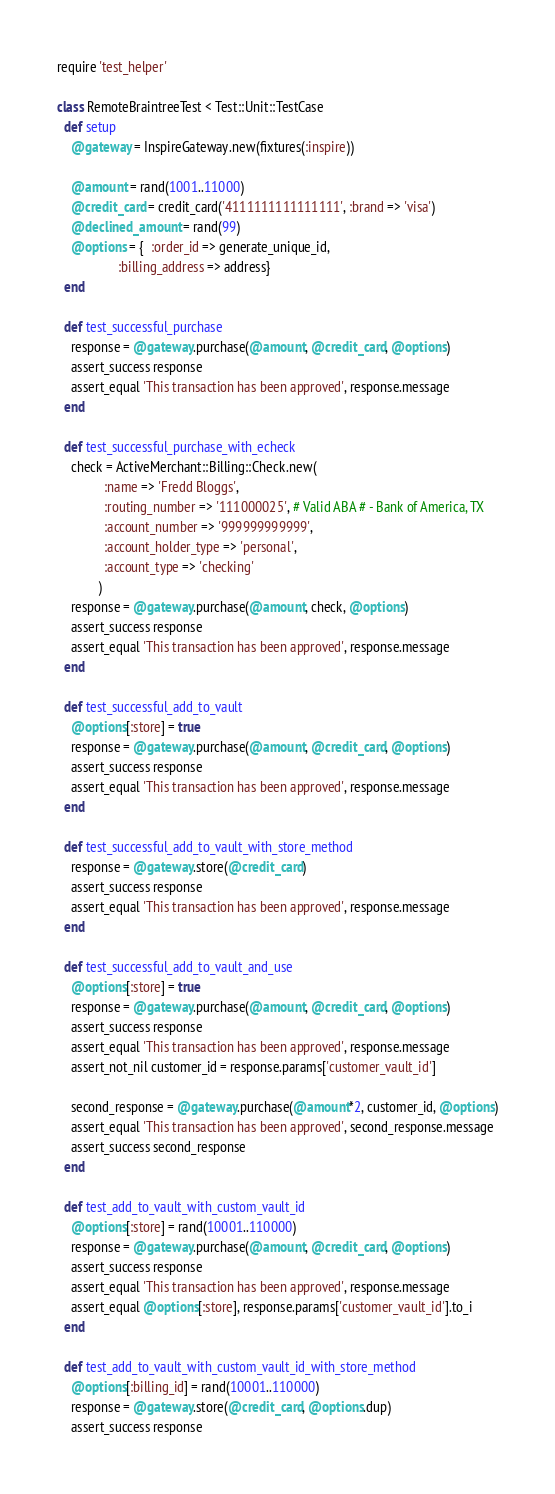<code> <loc_0><loc_0><loc_500><loc_500><_Ruby_>require 'test_helper'

class RemoteBraintreeTest < Test::Unit::TestCase
  def setup
    @gateway = InspireGateway.new(fixtures(:inspire))

    @amount = rand(1001..11000)
    @credit_card = credit_card('4111111111111111', :brand => 'visa')
    @declined_amount = rand(99)
    @options = {  :order_id => generate_unique_id,
                  :billing_address => address}
  end

  def test_successful_purchase
    response = @gateway.purchase(@amount, @credit_card, @options)
    assert_success response
    assert_equal 'This transaction has been approved', response.message
  end

  def test_successful_purchase_with_echeck
    check = ActiveMerchant::Billing::Check.new(
              :name => 'Fredd Bloggs',
              :routing_number => '111000025', # Valid ABA # - Bank of America, TX
              :account_number => '999999999999',
              :account_holder_type => 'personal',
              :account_type => 'checking'
            )
    response = @gateway.purchase(@amount, check, @options)
    assert_success response
    assert_equal 'This transaction has been approved', response.message
  end

  def test_successful_add_to_vault
    @options[:store] = true
    response = @gateway.purchase(@amount, @credit_card, @options)
    assert_success response
    assert_equal 'This transaction has been approved', response.message
  end

  def test_successful_add_to_vault_with_store_method
    response = @gateway.store(@credit_card)
    assert_success response
    assert_equal 'This transaction has been approved', response.message
  end

  def test_successful_add_to_vault_and_use
    @options[:store] = true
    response = @gateway.purchase(@amount, @credit_card, @options)
    assert_success response
    assert_equal 'This transaction has been approved', response.message
    assert_not_nil customer_id = response.params['customer_vault_id']

    second_response = @gateway.purchase(@amount*2, customer_id, @options)
    assert_equal 'This transaction has been approved', second_response.message
    assert_success second_response
  end

  def test_add_to_vault_with_custom_vault_id
    @options[:store] = rand(10001..110000)
    response = @gateway.purchase(@amount, @credit_card, @options)
    assert_success response
    assert_equal 'This transaction has been approved', response.message
    assert_equal @options[:store], response.params['customer_vault_id'].to_i
  end

  def test_add_to_vault_with_custom_vault_id_with_store_method
    @options[:billing_id] = rand(10001..110000)
    response = @gateway.store(@credit_card, @options.dup)
    assert_success response</code> 